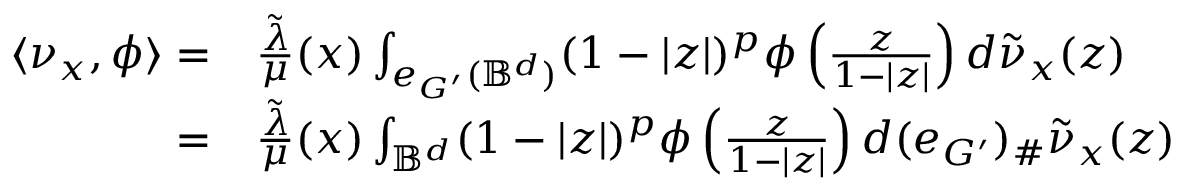Convert formula to latex. <formula><loc_0><loc_0><loc_500><loc_500>\begin{array} { r l } { \langle \nu _ { x } , \phi \rangle = } & { \frac { \tilde { \lambda } } { \mu } ( x ) \int _ { e _ { G ^ { \prime } } ( \mathbb { B } ^ { d } ) } ( 1 - | z | ) ^ { p } \phi \left ( \frac { z } { 1 - | z | } \right ) d \tilde { \nu } _ { x } ( z ) } \\ { = } & { \frac { \tilde { \lambda } } { \mu } ( x ) \int _ { \mathbb { B } ^ { d } } ( 1 - | z | ) ^ { p } \phi \left ( \frac { z } { 1 - | z | } \right ) d ( e _ { G ^ { \prime } } ) _ { \# } \tilde { \nu } _ { x } ( z ) } \end{array}</formula> 